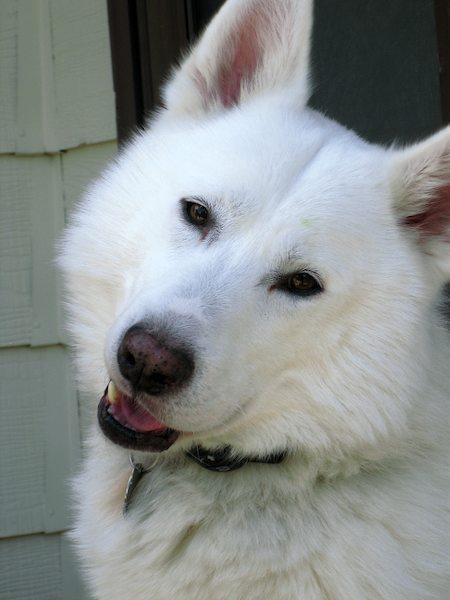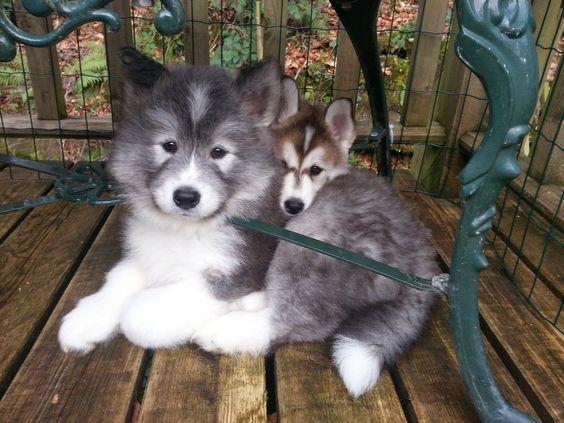The first image is the image on the left, the second image is the image on the right. Considering the images on both sides, is "A dog is looking toward the right side." valid? Answer yes or no. No. The first image is the image on the left, the second image is the image on the right. Assess this claim about the two images: "One image shows exactly one white dog with its ears flopped forward, and the other image shows one dog with 'salt-and-pepper' fur coloring, and all dogs shown are young instead of full grown.". Correct or not? Answer yes or no. No. 